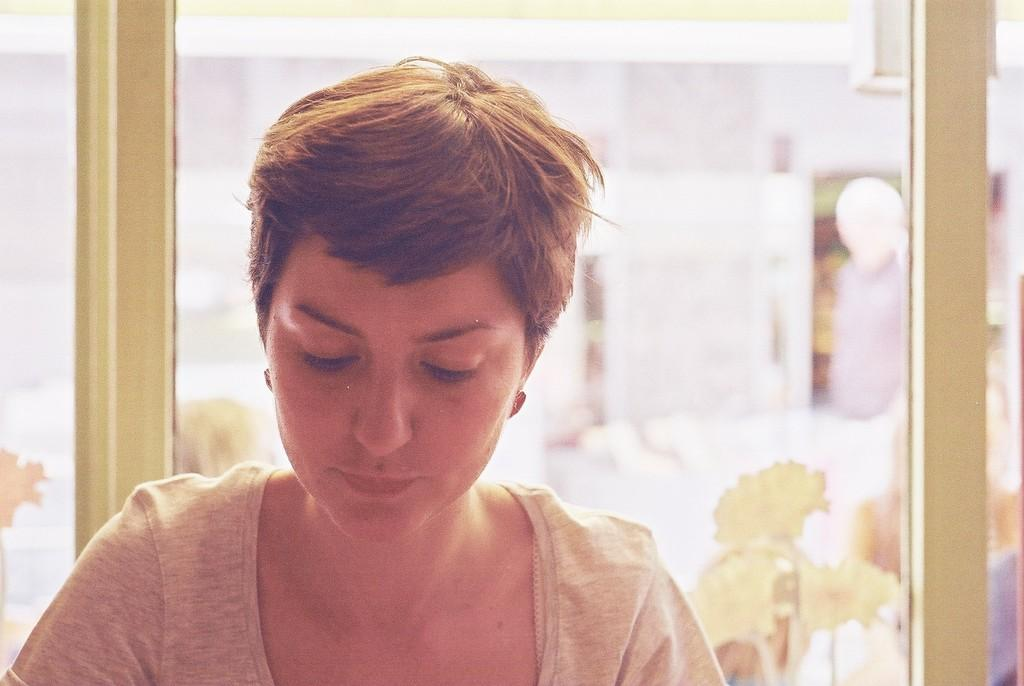Who or what is the main subject of the image? There is a person in the image. Can you describe the background of the image? The background of the image is blurred. What can be observed about the person's attire in the image? The person in the image is wearing clothes. What type of tramp can be seen in the image? There is no tramp present in the image. How does the acoustics of the room affect the person in the image? The provided facts do not mention anything about the acoustics of the room, so we cannot determine how it affects the person in the image. 